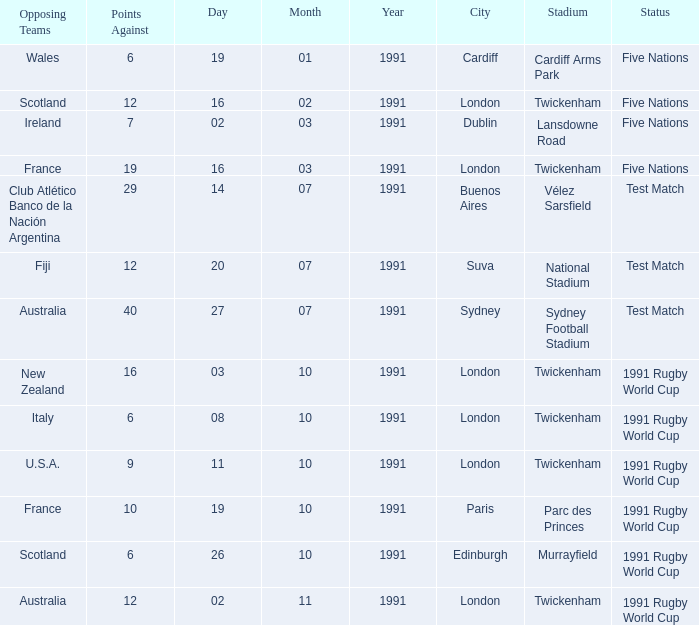What is Opposing Teams, when Date is "11/10/1991"? U.S.A. 